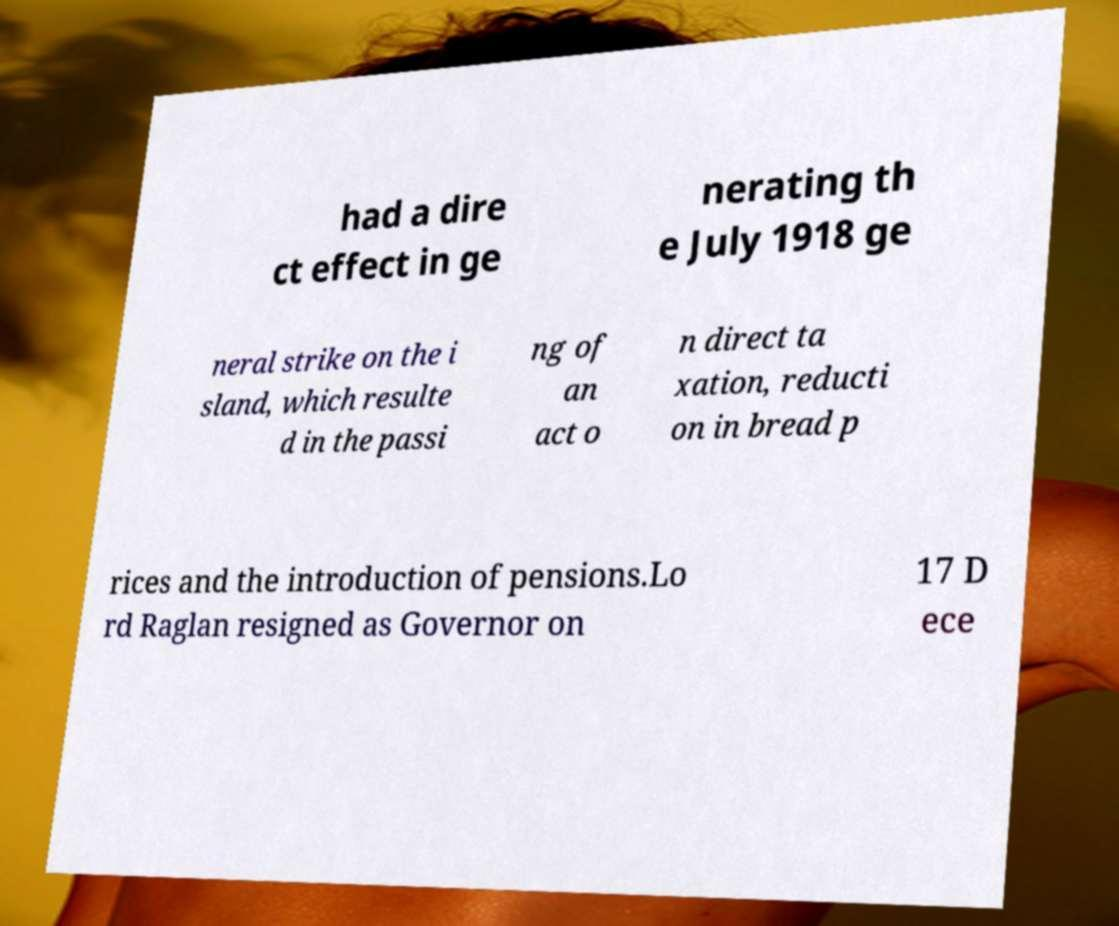Could you extract and type out the text from this image? had a dire ct effect in ge nerating th e July 1918 ge neral strike on the i sland, which resulte d in the passi ng of an act o n direct ta xation, reducti on in bread p rices and the introduction of pensions.Lo rd Raglan resigned as Governor on 17 D ece 